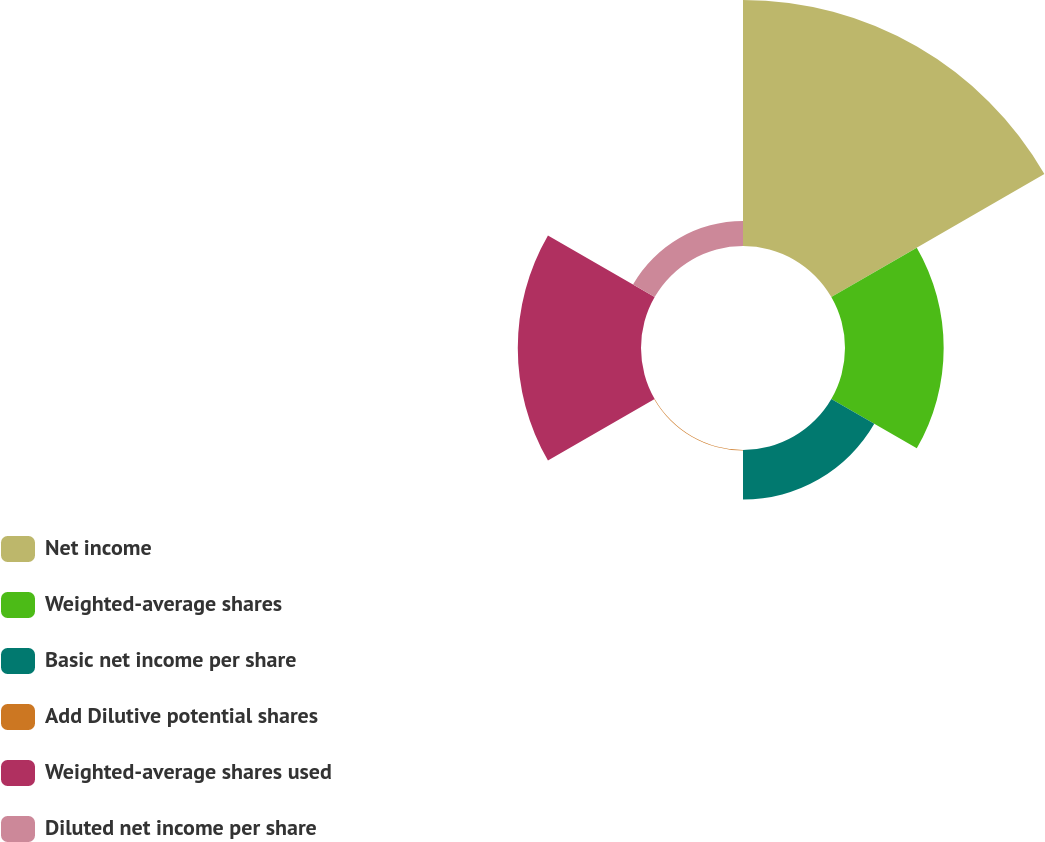Convert chart. <chart><loc_0><loc_0><loc_500><loc_500><pie_chart><fcel>Net income<fcel>Weighted-average shares<fcel>Basic net income per share<fcel>Add Dilutive potential shares<fcel>Weighted-average shares used<fcel>Diluted net income per share<nl><fcel>45.3%<fcel>18.17%<fcel>9.13%<fcel>0.09%<fcel>22.69%<fcel>4.61%<nl></chart> 